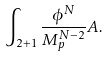<formula> <loc_0><loc_0><loc_500><loc_500>\int _ { 2 + 1 } \frac { \phi ^ { N } } { M _ { p } ^ { N - 2 } } A .</formula> 